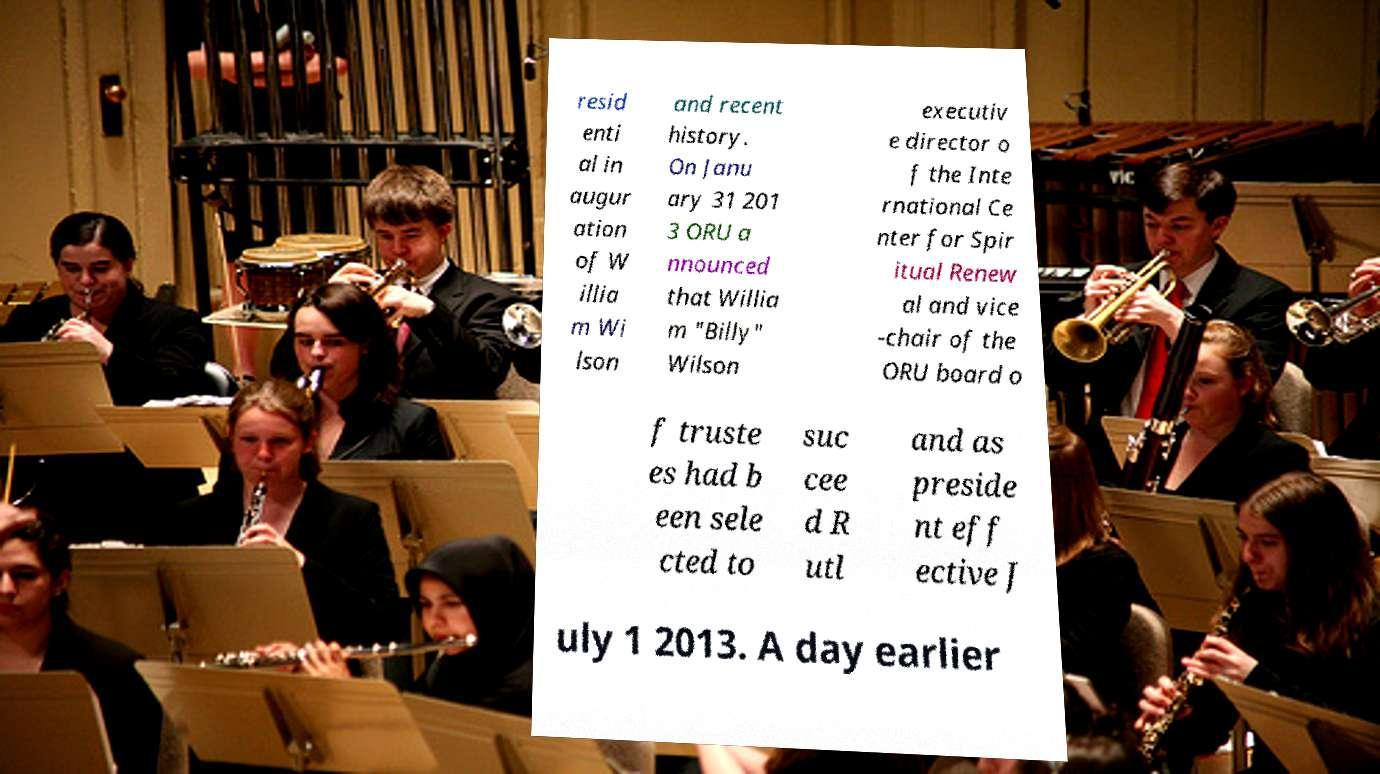Please read and relay the text visible in this image. What does it say? resid enti al in augur ation of W illia m Wi lson and recent history. On Janu ary 31 201 3 ORU a nnounced that Willia m "Billy" Wilson executiv e director o f the Inte rnational Ce nter for Spir itual Renew al and vice -chair of the ORU board o f truste es had b een sele cted to suc cee d R utl and as preside nt eff ective J uly 1 2013. A day earlier 